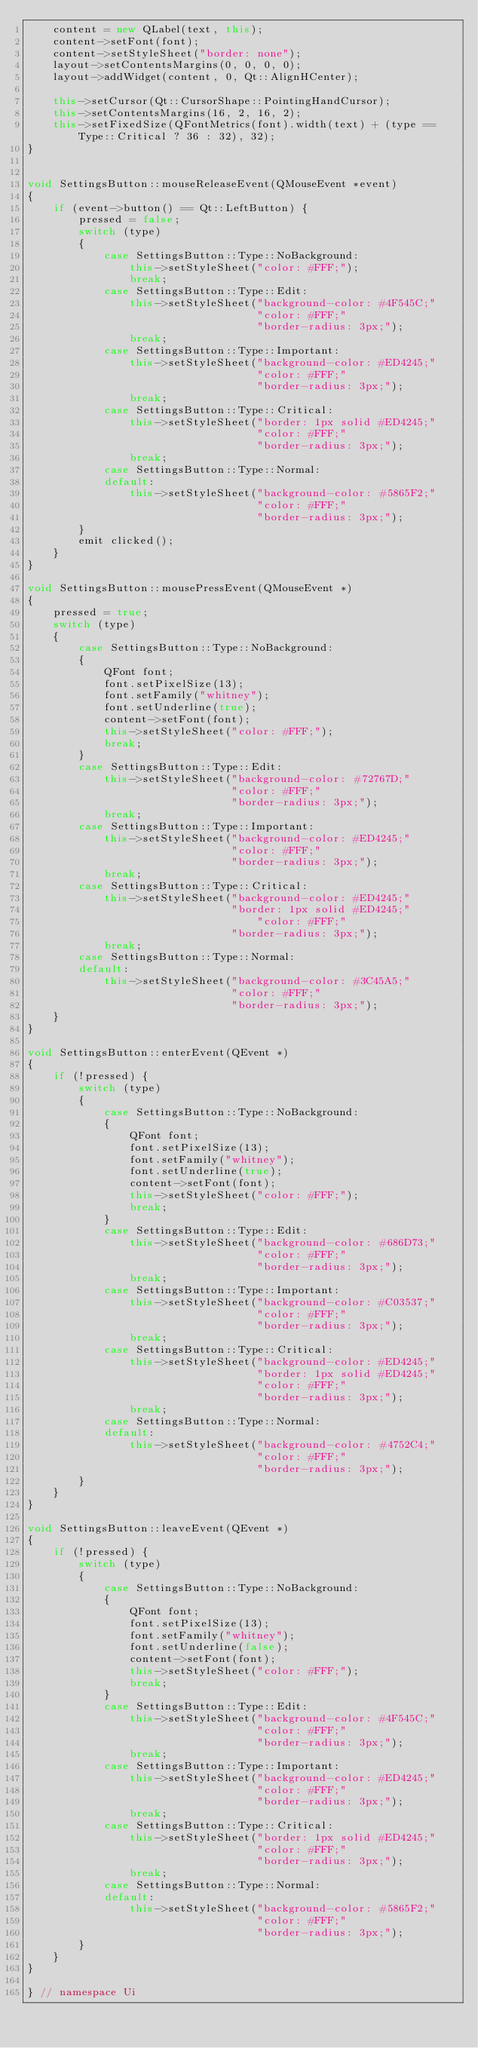<code> <loc_0><loc_0><loc_500><loc_500><_C++_>    content = new QLabel(text, this);
    content->setFont(font);
    content->setStyleSheet("border: none");
    layout->setContentsMargins(0, 0, 0, 0);
    layout->addWidget(content, 0, Qt::AlignHCenter);

    this->setCursor(Qt::CursorShape::PointingHandCursor);
    this->setContentsMargins(16, 2, 16, 2);
    this->setFixedSize(QFontMetrics(font).width(text) + (type == Type::Critical ? 36 : 32), 32);
}


void SettingsButton::mouseReleaseEvent(QMouseEvent *event)
{
    if (event->button() == Qt::LeftButton) {
        pressed = false;
        switch (type)
        {
            case SettingsButton::Type::NoBackground:
                this->setStyleSheet("color: #FFF;");
                break;
            case SettingsButton::Type::Edit:
                this->setStyleSheet("background-color: #4F545C;"
                                    "color: #FFF;"
                                    "border-radius: 3px;");
                break;
            case SettingsButton::Type::Important:
                this->setStyleSheet("background-color: #ED4245;"
                                    "color: #FFF;"
                                    "border-radius: 3px;");
                break;
            case SettingsButton::Type::Critical:
                this->setStyleSheet("border: 1px solid #ED4245;"
                                    "color: #FFF;"
                                    "border-radius: 3px;");
                break;
            case SettingsButton::Type::Normal:    
            default:
                this->setStyleSheet("background-color: #5865F2;"
                                    "color: #FFF;"
                                    "border-radius: 3px;");
        }
        emit clicked();
    }
}

void SettingsButton::mousePressEvent(QMouseEvent *)
{
    pressed = true;
    switch (type)
    {
        case SettingsButton::Type::NoBackground:
        {
            QFont font;
            font.setPixelSize(13);
            font.setFamily("whitney");
            font.setUnderline(true);
            content->setFont(font);
            this->setStyleSheet("color: #FFF;");
            break;
        }
        case SettingsButton::Type::Edit:
            this->setStyleSheet("background-color: #72767D;"
                                "color: #FFF;"
                                "border-radius: 3px;");
            break;
        case SettingsButton::Type::Important:
            this->setStyleSheet("background-color: #ED4245;"
                                "color: #FFF;"
                                "border-radius: 3px;");
            break;
        case SettingsButton::Type::Critical:
            this->setStyleSheet("background-color: #ED4245;"
                                "border: 1px solid #ED4245;"
                                    "color: #FFF;"
                                "border-radius: 3px;");
            break;
        case SettingsButton::Type::Normal:    
        default:
            this->setStyleSheet("background-color: #3C45A5;"
                                "color: #FFF;"
                                "border-radius: 3px;");
    }
}

void SettingsButton::enterEvent(QEvent *)
{
    if (!pressed) {
        switch (type)
        {
            case SettingsButton::Type::NoBackground:
            {
                QFont font;
                font.setPixelSize(13);
                font.setFamily("whitney");
                font.setUnderline(true);
                content->setFont(font);
                this->setStyleSheet("color: #FFF;");
                break;
            }
            case SettingsButton::Type::Edit:
                this->setStyleSheet("background-color: #686D73;"
                                    "color: #FFF;"
                                    "border-radius: 3px;");
                break;
            case SettingsButton::Type::Important:
                this->setStyleSheet("background-color: #C03537;"
                                    "color: #FFF;"
                                    "border-radius: 3px;");
                break;
            case SettingsButton::Type::Critical:
                this->setStyleSheet("background-color: #ED4245;"
                                    "border: 1px solid #ED4245;"
                                    "color: #FFF;"
                                    "border-radius: 3px;");
                break;
            case SettingsButton::Type::Normal:    
            default:
                this->setStyleSheet("background-color: #4752C4;"
                                    "color: #FFF;"
                                    "border-radius: 3px;");
        }
    }
}

void SettingsButton::leaveEvent(QEvent *)
{
    if (!pressed) {
        switch (type)
        {
            case SettingsButton::Type::NoBackground:
            {
                QFont font;
                font.setPixelSize(13);
                font.setFamily("whitney");
                font.setUnderline(false);
                content->setFont(font);
                this->setStyleSheet("color: #FFF;");
                break;
            }
            case SettingsButton::Type::Edit:
                this->setStyleSheet("background-color: #4F545C;"
                                    "color: #FFF;"
                                    "border-radius: 3px;");
                break;
            case SettingsButton::Type::Important:
                this->setStyleSheet("background-color: #ED4245;"
                                    "color: #FFF;"
                                    "border-radius: 3px;");
                break;
            case SettingsButton::Type::Critical:
                this->setStyleSheet("border: 1px solid #ED4245;"
                                    "color: #FFF;"
                                    "border-radius: 3px;");
                break;
            case SettingsButton::Type::Normal:    
            default:
                this->setStyleSheet("background-color: #5865F2;"
                                    "color: #FFF;"
                                    "border-radius: 3px;");
        }
    }
}

} // namespace Ui</code> 